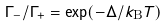<formula> <loc_0><loc_0><loc_500><loc_500>\Gamma _ { - } / \Gamma _ { + } = \exp ( - \Delta / k _ { \text {B} } T )</formula> 